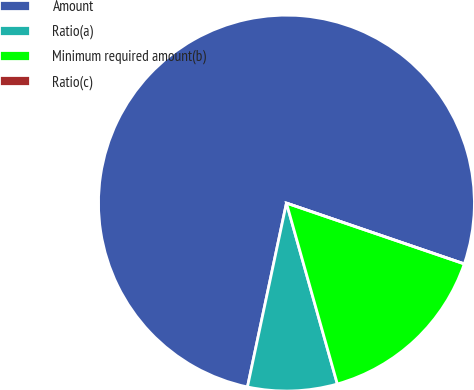Convert chart to OTSL. <chart><loc_0><loc_0><loc_500><loc_500><pie_chart><fcel>Amount<fcel>Ratio(a)<fcel>Minimum required amount(b)<fcel>Ratio(c)<nl><fcel>76.92%<fcel>7.69%<fcel>15.39%<fcel>0.0%<nl></chart> 